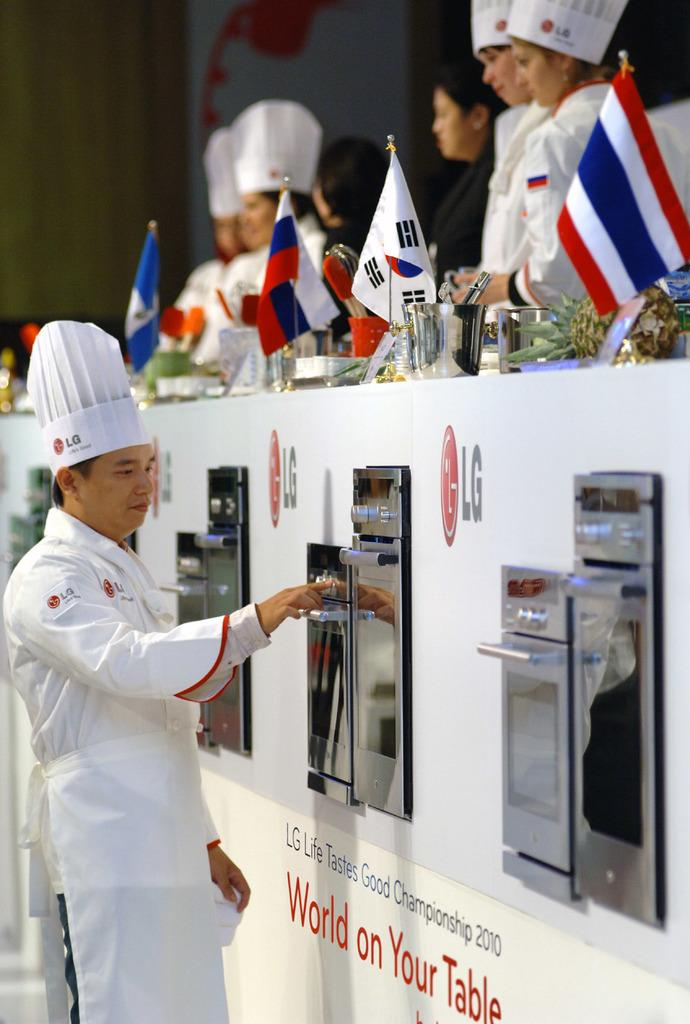<image>
Present a compact description of the photo's key features. a chef is pulling things from an oven on a wall with the words World on your Table 